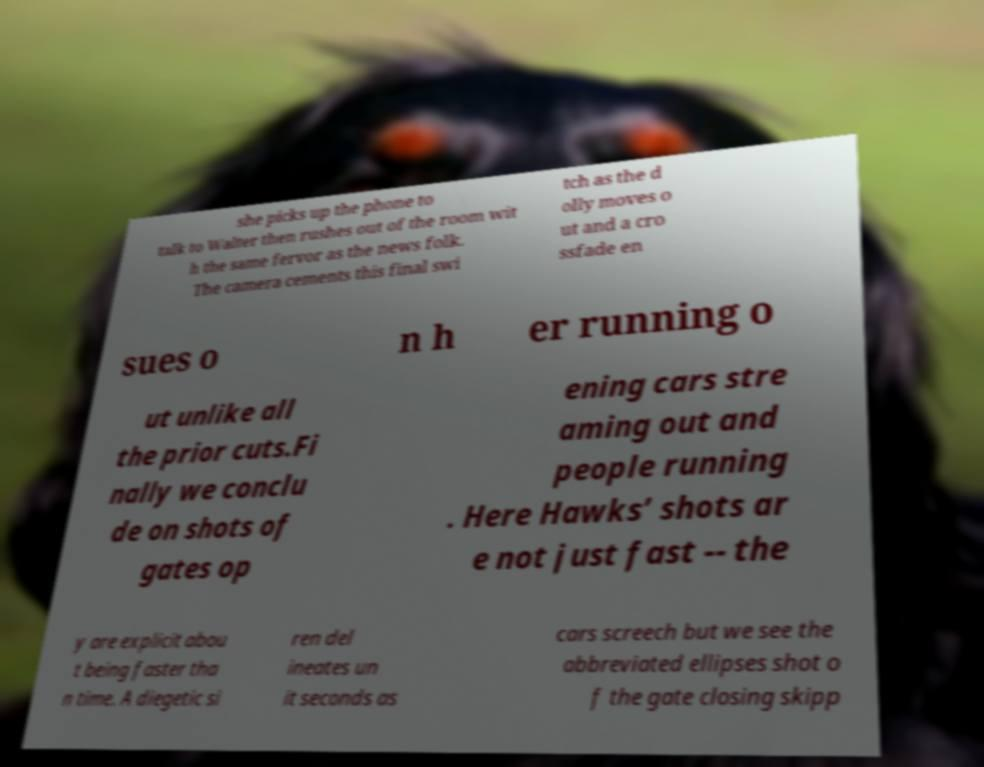What messages or text are displayed in this image? I need them in a readable, typed format. she picks up the phone to talk to Walter then rushes out of the room wit h the same fervor as the news folk. The camera cements this final swi tch as the d olly moves o ut and a cro ssfade en sues o n h er running o ut unlike all the prior cuts.Fi nally we conclu de on shots of gates op ening cars stre aming out and people running . Here Hawks’ shots ar e not just fast -- the y are explicit abou t being faster tha n time. A diegetic si ren del ineates un it seconds as cars screech but we see the abbreviated ellipses shot o f the gate closing skipp 